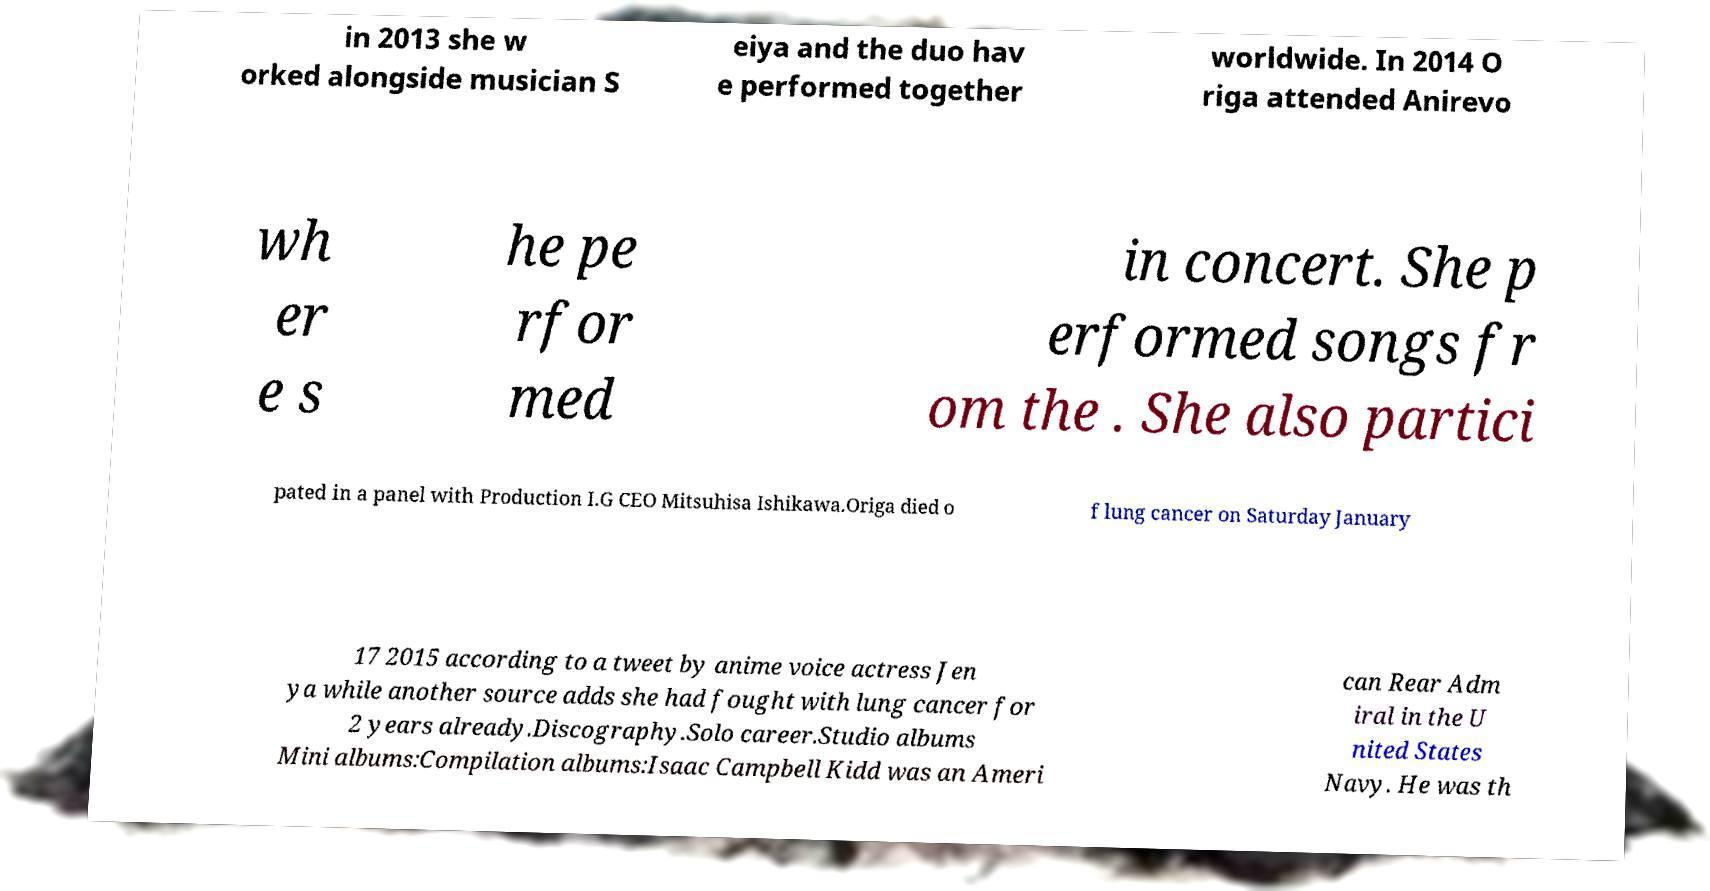Please identify and transcribe the text found in this image. in 2013 she w orked alongside musician S eiya and the duo hav e performed together worldwide. In 2014 O riga attended Anirevo wh er e s he pe rfor med in concert. She p erformed songs fr om the . She also partici pated in a panel with Production I.G CEO Mitsuhisa Ishikawa.Origa died o f lung cancer on Saturday January 17 2015 according to a tweet by anime voice actress Jen ya while another source adds she had fought with lung cancer for 2 years already.Discography.Solo career.Studio albums Mini albums:Compilation albums:Isaac Campbell Kidd was an Ameri can Rear Adm iral in the U nited States Navy. He was th 